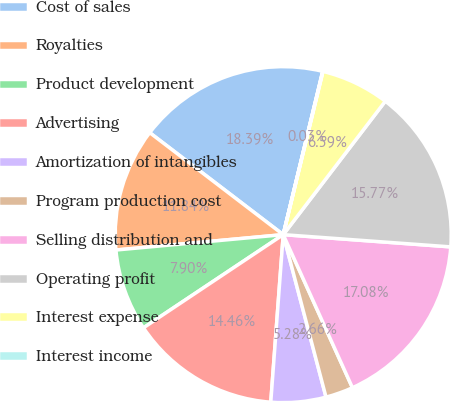<chart> <loc_0><loc_0><loc_500><loc_500><pie_chart><fcel>Cost of sales<fcel>Royalties<fcel>Product development<fcel>Advertising<fcel>Amortization of intangibles<fcel>Program production cost<fcel>Selling distribution and<fcel>Operating profit<fcel>Interest expense<fcel>Interest income<nl><fcel>18.39%<fcel>11.84%<fcel>7.9%<fcel>14.46%<fcel>5.28%<fcel>2.66%<fcel>17.08%<fcel>15.77%<fcel>6.59%<fcel>0.03%<nl></chart> 